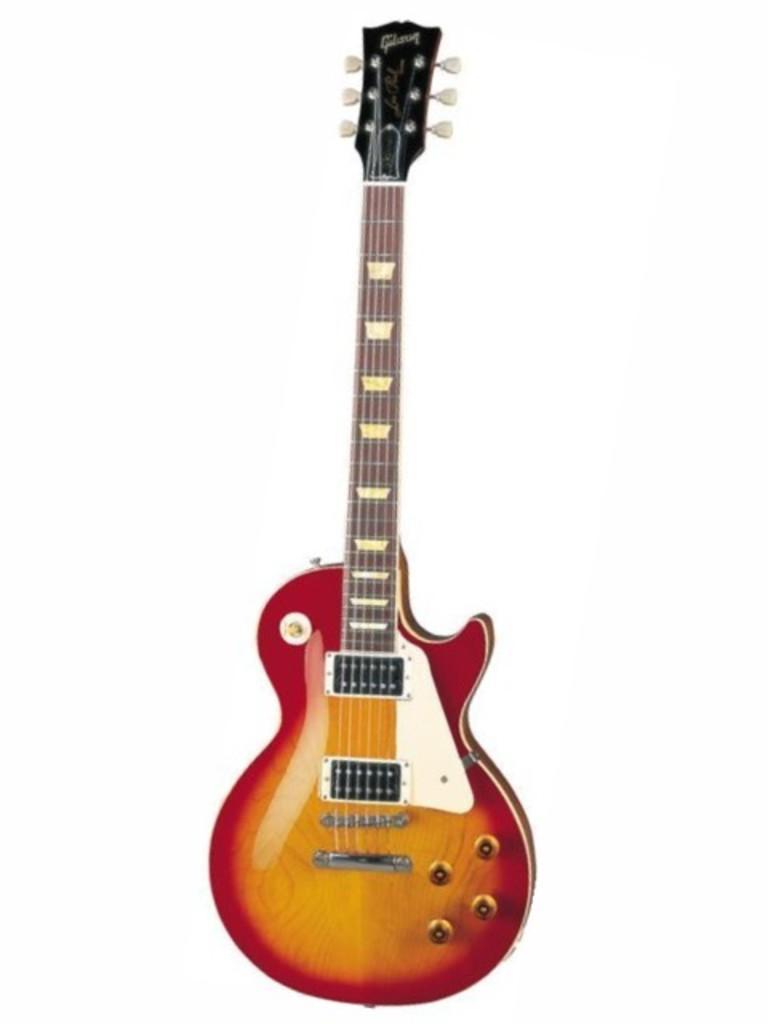Could you give a brief overview of what you see in this image? Red and yellow color guitar with strings to it and this is in standing position. 